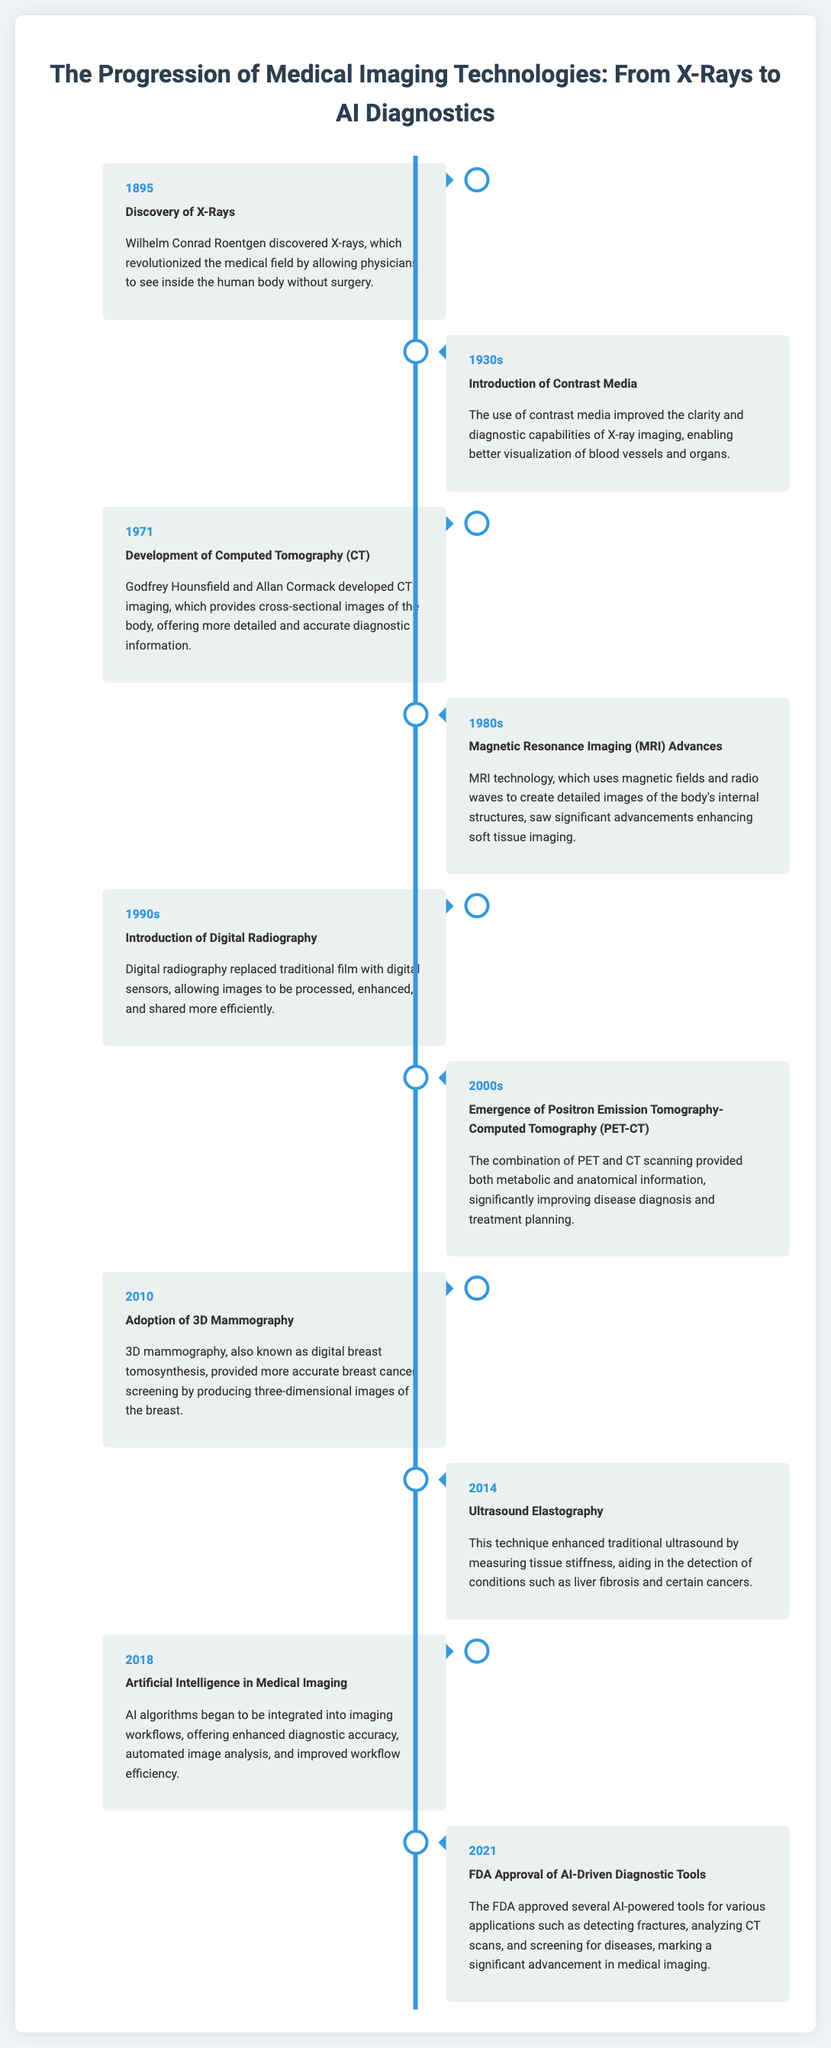What year was X-Rays discovered? The document states that X-Rays were discovered in 1895.
Answer: 1895 Who discovered X-Rays? The document attributes the discovery of X-Rays to Wilhelm Conrad Roentgen.
Answer: Wilhelm Conrad Roentgen What imaging technology was developed in 1971? The timeline mentions the development of Computed Tomography (CT) in 1971.
Answer: Computed Tomography (CT) What significant advancement occurred in the 1980s? The timeline notes that MRI technology saw significant advancements during the 1980s.
Answer: MRI technology What does the year 2010 signify in the timeline? The document states that 2010 marks the adoption of 3D Mammography.
Answer: Adoption of 3D Mammography What major integration began in 2018? According to the timeline, Artificial Intelligence started to be integrated into imaging workflows in 2018.
Answer: Artificial Intelligence In what year did the FDA approve AI-driven diagnostic tools? The timeline indicates that the FDA approved these tools in 2021.
Answer: 2021 What was the purpose of introducing contrast media in the 1930s? The document explains that contrast media improved clarity and diagnostic capabilities of X-ray imaging.
Answer: Improved clarity and diagnostic capabilities Which two technologies were combined in 2000s? The timeline mentions the emergence of Positron Emission Tomography-Computed Tomography (PET-CT).
Answer: PET-CT 